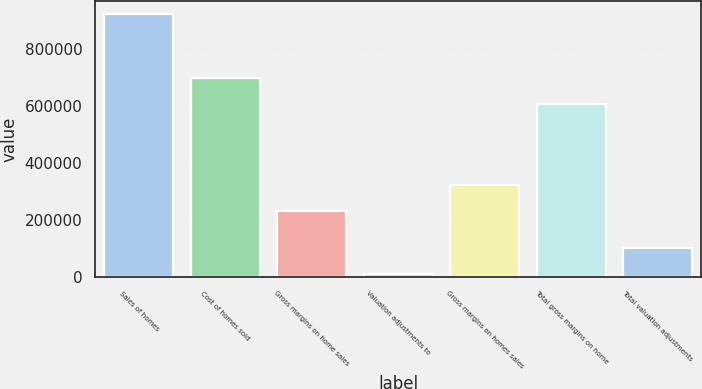<chart> <loc_0><loc_0><loc_500><loc_500><bar_chart><fcel>Sales of homes<fcel>Cost of homes sold<fcel>Gross margins on home sales<fcel>Valuation adjustments to<fcel>Gross margins on homes sales<fcel>Total gross margins on home<fcel>Total valuation adjustments<nl><fcel>922947<fcel>700428<fcel>232363<fcel>10410<fcel>323617<fcel>609175<fcel>101664<nl></chart> 